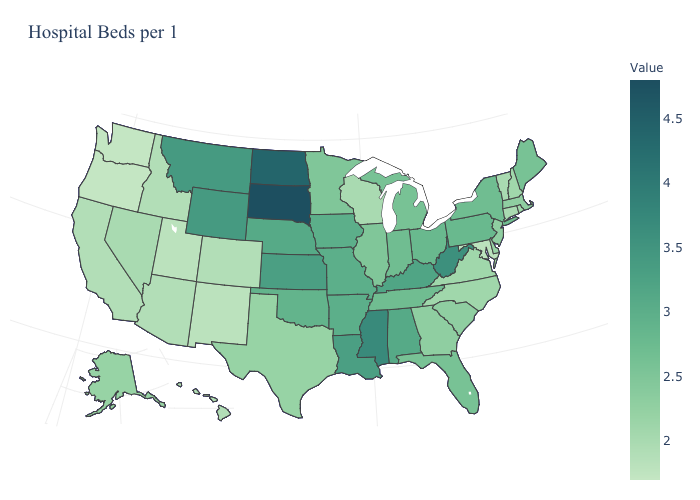Does Wyoming have the lowest value in the West?
Give a very brief answer. No. Among the states that border Arkansas , which have the lowest value?
Write a very short answer. Texas. Does Wyoming have the highest value in the USA?
Keep it brief. No. Does Montana have the highest value in the West?
Answer briefly. Yes. Does Massachusetts have the lowest value in the Northeast?
Be succinct. No. 